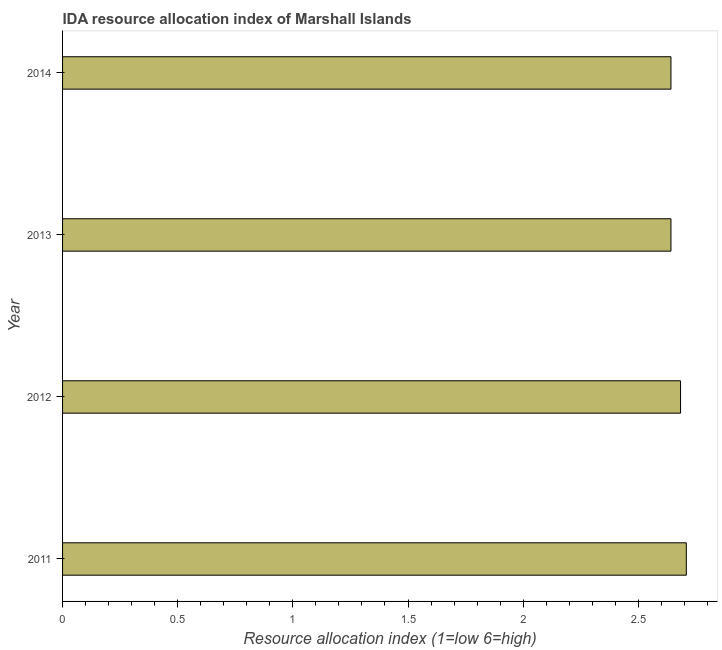Does the graph contain grids?
Ensure brevity in your answer.  No. What is the title of the graph?
Provide a short and direct response. IDA resource allocation index of Marshall Islands. What is the label or title of the X-axis?
Offer a terse response. Resource allocation index (1=low 6=high). What is the ida resource allocation index in 2011?
Offer a terse response. 2.71. Across all years, what is the maximum ida resource allocation index?
Your response must be concise. 2.71. Across all years, what is the minimum ida resource allocation index?
Give a very brief answer. 2.64. In which year was the ida resource allocation index maximum?
Give a very brief answer. 2011. In which year was the ida resource allocation index minimum?
Your answer should be very brief. 2013. What is the sum of the ida resource allocation index?
Offer a terse response. 10.68. What is the difference between the ida resource allocation index in 2012 and 2013?
Your response must be concise. 0.04. What is the average ida resource allocation index per year?
Your answer should be very brief. 2.67. What is the median ida resource allocation index?
Ensure brevity in your answer.  2.66. Is the difference between the ida resource allocation index in 2011 and 2014 greater than the difference between any two years?
Your response must be concise. No. What is the difference between the highest and the second highest ida resource allocation index?
Provide a short and direct response. 0.03. Is the sum of the ida resource allocation index in 2013 and 2014 greater than the maximum ida resource allocation index across all years?
Give a very brief answer. Yes. What is the difference between the highest and the lowest ida resource allocation index?
Give a very brief answer. 0.07. In how many years, is the ida resource allocation index greater than the average ida resource allocation index taken over all years?
Offer a terse response. 2. What is the difference between two consecutive major ticks on the X-axis?
Ensure brevity in your answer.  0.5. Are the values on the major ticks of X-axis written in scientific E-notation?
Offer a very short reply. No. What is the Resource allocation index (1=low 6=high) in 2011?
Make the answer very short. 2.71. What is the Resource allocation index (1=low 6=high) in 2012?
Give a very brief answer. 2.68. What is the Resource allocation index (1=low 6=high) in 2013?
Offer a very short reply. 2.64. What is the Resource allocation index (1=low 6=high) of 2014?
Keep it short and to the point. 2.64. What is the difference between the Resource allocation index (1=low 6=high) in 2011 and 2012?
Your answer should be compact. 0.03. What is the difference between the Resource allocation index (1=low 6=high) in 2011 and 2013?
Give a very brief answer. 0.07. What is the difference between the Resource allocation index (1=low 6=high) in 2011 and 2014?
Offer a very short reply. 0.07. What is the difference between the Resource allocation index (1=low 6=high) in 2012 and 2013?
Your answer should be compact. 0.04. What is the difference between the Resource allocation index (1=low 6=high) in 2012 and 2014?
Ensure brevity in your answer.  0.04. What is the difference between the Resource allocation index (1=low 6=high) in 2013 and 2014?
Your answer should be very brief. -0. What is the ratio of the Resource allocation index (1=low 6=high) in 2011 to that in 2013?
Make the answer very short. 1.02. What is the ratio of the Resource allocation index (1=low 6=high) in 2011 to that in 2014?
Give a very brief answer. 1.02. What is the ratio of the Resource allocation index (1=low 6=high) in 2012 to that in 2013?
Offer a very short reply. 1.02. 